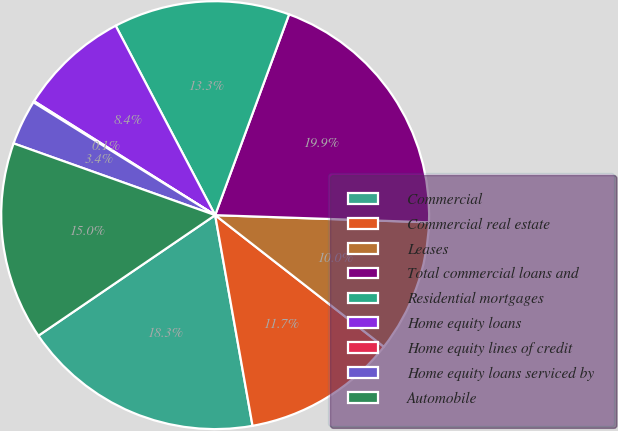Convert chart. <chart><loc_0><loc_0><loc_500><loc_500><pie_chart><fcel>Commercial<fcel>Commercial real estate<fcel>Leases<fcel>Total commercial loans and<fcel>Residential mortgages<fcel>Home equity loans<fcel>Home equity lines of credit<fcel>Home equity loans serviced by<fcel>Automobile<nl><fcel>18.27%<fcel>11.66%<fcel>10.01%<fcel>19.92%<fcel>13.31%<fcel>8.36%<fcel>0.1%<fcel>3.4%<fcel>14.97%<nl></chart> 